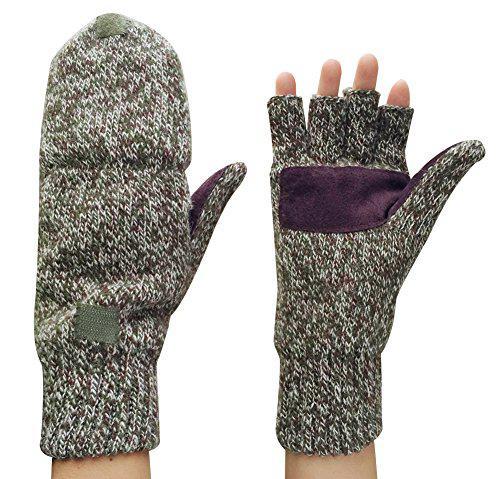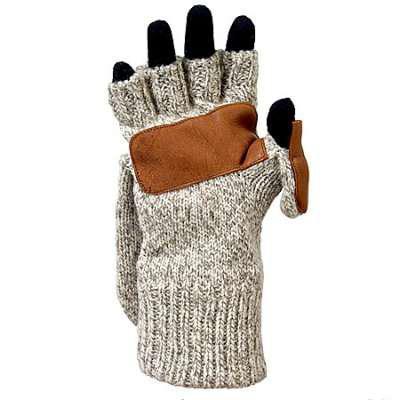The first image is the image on the left, the second image is the image on the right. Examine the images to the left and right. Is the description "Each image shows a complete pair of mittens." accurate? Answer yes or no. No. The first image is the image on the left, the second image is the image on the right. Given the left and right images, does the statement "An image shows one fingerless glove over black """"fingers""""." hold true? Answer yes or no. Yes. 